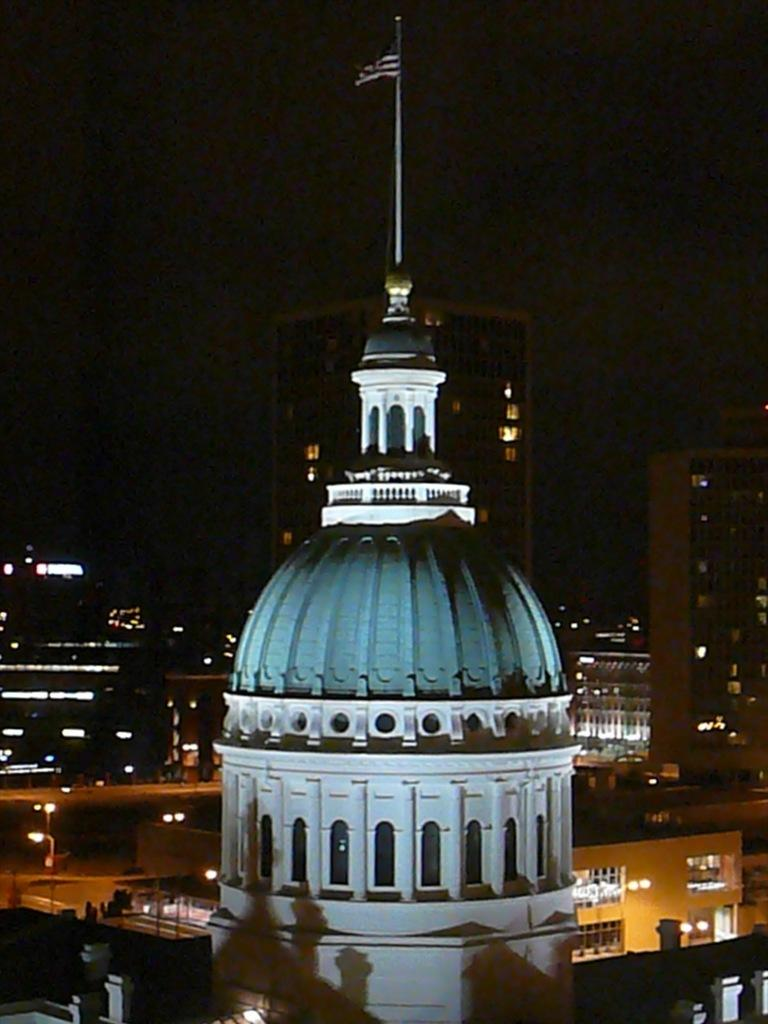What is located in the center of the image? There are buildings in the center of the image. What can be seen in the image besides the buildings? Lights, a pole, and a flag are present in the image. What is visible at the top of the image? The sky is visible at the top of the image. What type of potato is being used as a pet in the image? There is no potato or pet present in the image. What kind of boot can be seen on the pole in the image? There is no boot present on the pole in the image. 